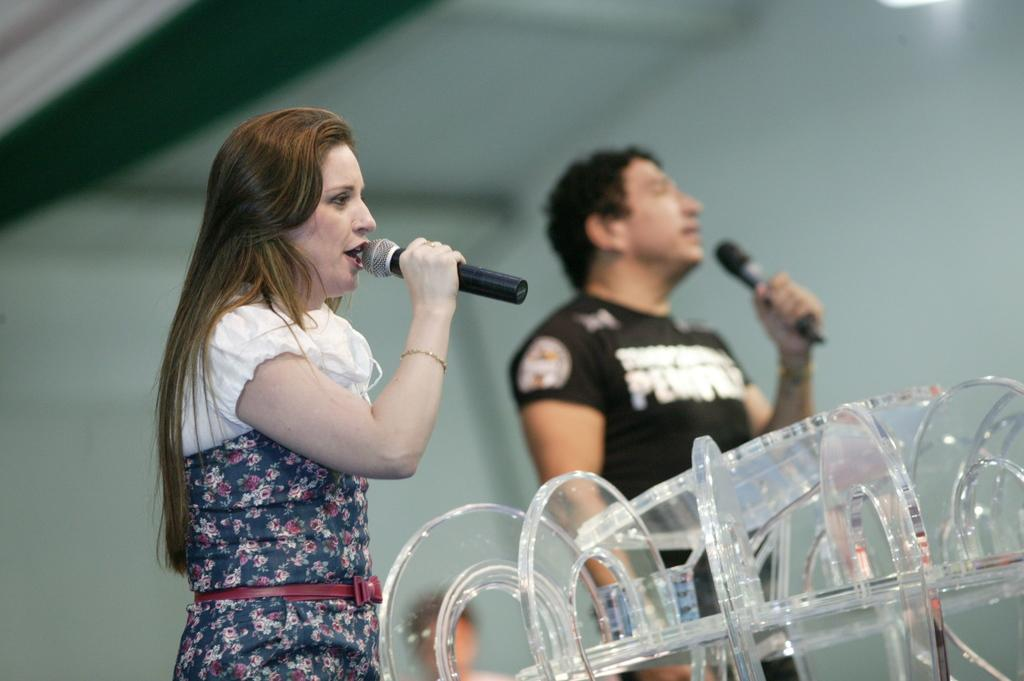How many people are in the image? There are two persons in the image. What are the persons wearing? The persons are wearing clothes. What are the persons holding in their hands? The persons are holding mics in their hands. Can you describe the object in the bottom right of the image? Unfortunately, the provided facts do not give enough information to describe the object in the bottom right of the image. What can be said about the background of the image? The background of the image is blurred. What type of fowl can be seen swimming in the lake in the image? There is no lake or fowl present in the image. Can you tell me how many requests the persons in the image have received? There is no information about requests in the image. 